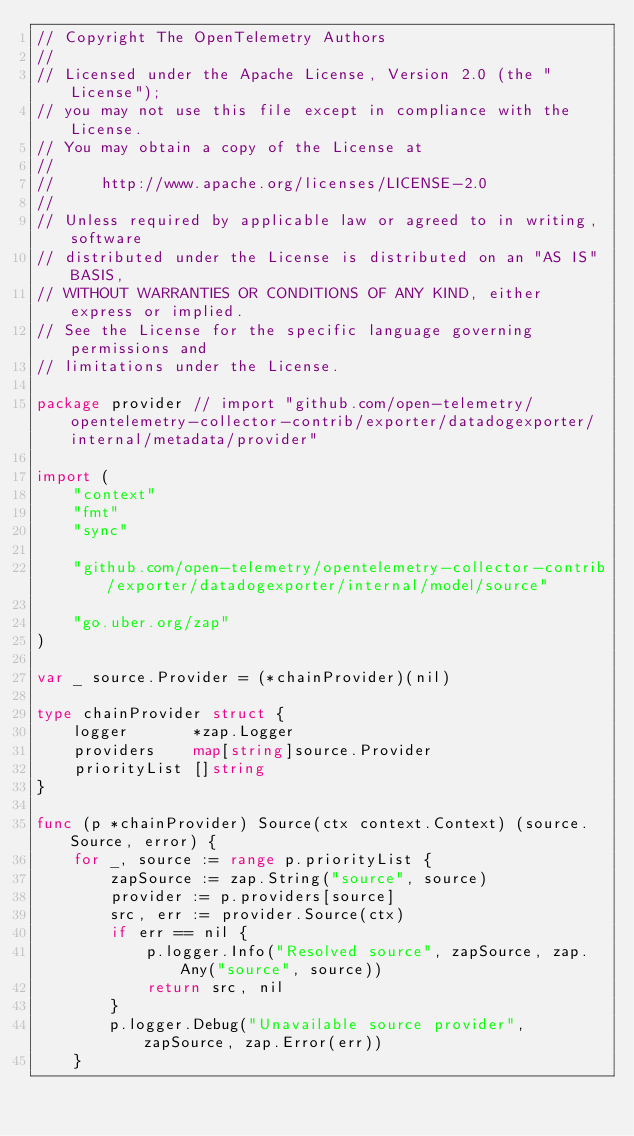Convert code to text. <code><loc_0><loc_0><loc_500><loc_500><_Go_>// Copyright The OpenTelemetry Authors
//
// Licensed under the Apache License, Version 2.0 (the "License");
// you may not use this file except in compliance with the License.
// You may obtain a copy of the License at
//
//     http://www.apache.org/licenses/LICENSE-2.0
//
// Unless required by applicable law or agreed to in writing, software
// distributed under the License is distributed on an "AS IS" BASIS,
// WITHOUT WARRANTIES OR CONDITIONS OF ANY KIND, either express or implied.
// See the License for the specific language governing permissions and
// limitations under the License.

package provider // import "github.com/open-telemetry/opentelemetry-collector-contrib/exporter/datadogexporter/internal/metadata/provider"

import (
	"context"
	"fmt"
	"sync"

	"github.com/open-telemetry/opentelemetry-collector-contrib/exporter/datadogexporter/internal/model/source"

	"go.uber.org/zap"
)

var _ source.Provider = (*chainProvider)(nil)

type chainProvider struct {
	logger       *zap.Logger
	providers    map[string]source.Provider
	priorityList []string
}

func (p *chainProvider) Source(ctx context.Context) (source.Source, error) {
	for _, source := range p.priorityList {
		zapSource := zap.String("source", source)
		provider := p.providers[source]
		src, err := provider.Source(ctx)
		if err == nil {
			p.logger.Info("Resolved source", zapSource, zap.Any("source", source))
			return src, nil
		}
		p.logger.Debug("Unavailable source provider", zapSource, zap.Error(err))
	}
</code> 